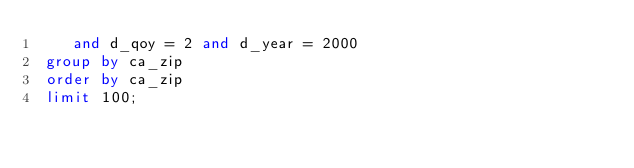Convert code to text. <code><loc_0><loc_0><loc_500><loc_500><_SQL_>    and d_qoy = 2 and d_year = 2000
 group by ca_zip
 order by ca_zip
 limit 100;



</code> 